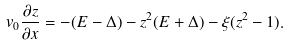<formula> <loc_0><loc_0><loc_500><loc_500>v _ { 0 } \frac { \partial z } { \partial x } = - ( E - \Delta ) - z ^ { 2 } ( E + \Delta ) - \xi ( z ^ { 2 } - 1 ) .</formula> 